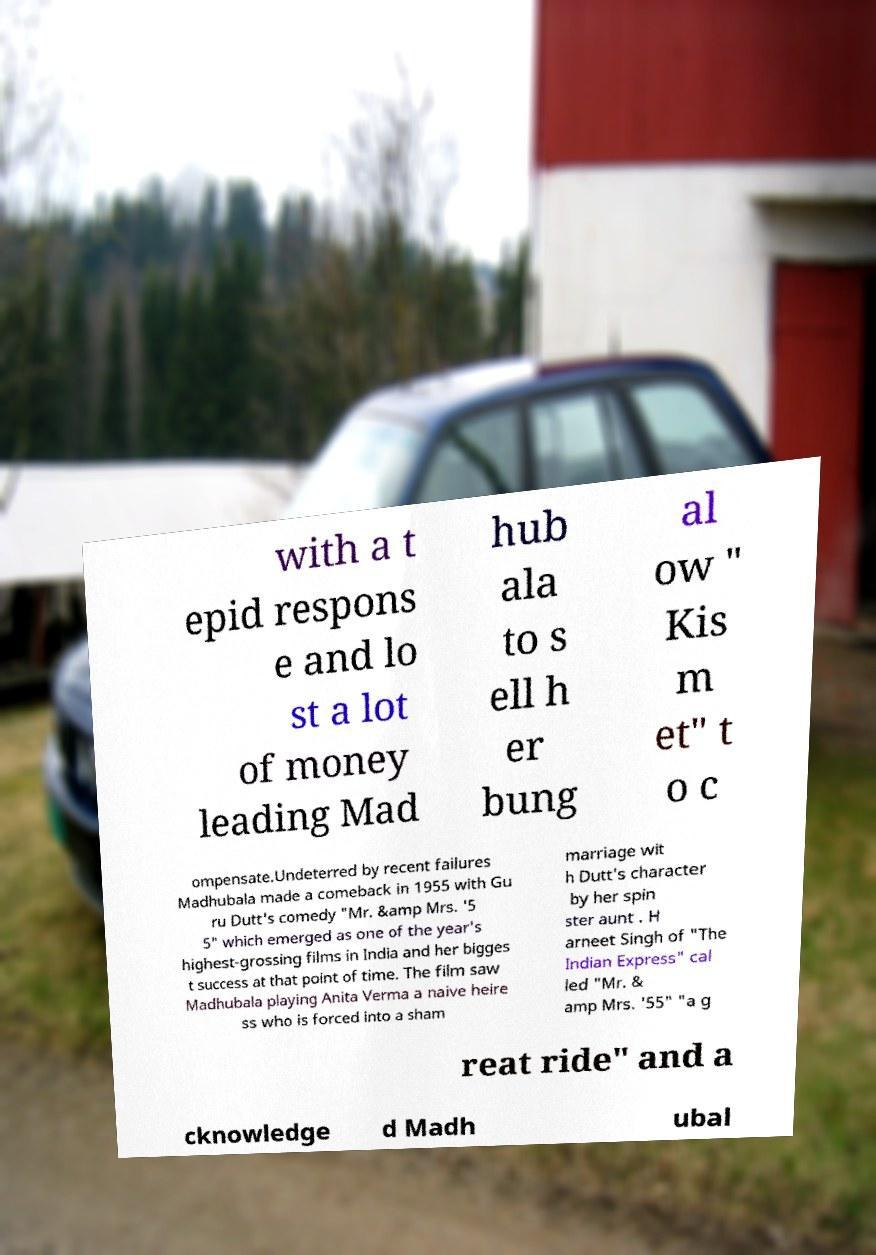Can you read and provide the text displayed in the image?This photo seems to have some interesting text. Can you extract and type it out for me? with a t epid respons e and lo st a lot of money leading Mad hub ala to s ell h er bung al ow " Kis m et" t o c ompensate.Undeterred by recent failures Madhubala made a comeback in 1955 with Gu ru Dutt's comedy "Mr. &amp Mrs. '5 5" which emerged as one of the year's highest-grossing films in India and her bigges t success at that point of time. The film saw Madhubala playing Anita Verma a naive heire ss who is forced into a sham marriage wit h Dutt's character by her spin ster aunt . H arneet Singh of "The Indian Express" cal led "Mr. & amp Mrs. '55" "a g reat ride" and a cknowledge d Madh ubal 